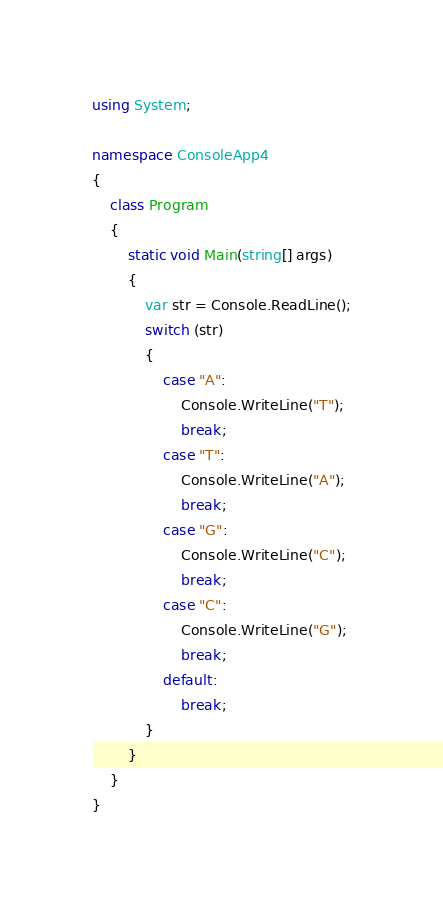<code> <loc_0><loc_0><loc_500><loc_500><_C#_>using System;

namespace ConsoleApp4
{
    class Program
    {
        static void Main(string[] args)
        {
            var str = Console.ReadLine();
            switch (str)
            {
                case "A":
                    Console.WriteLine("T");
                    break;
                case "T":
                    Console.WriteLine("A");
                    break;
                case "G":
                    Console.WriteLine("C");
                    break;
                case "C":
                    Console.WriteLine("G");
                    break;
                default:
                    break;
            }
        }
    }
}</code> 